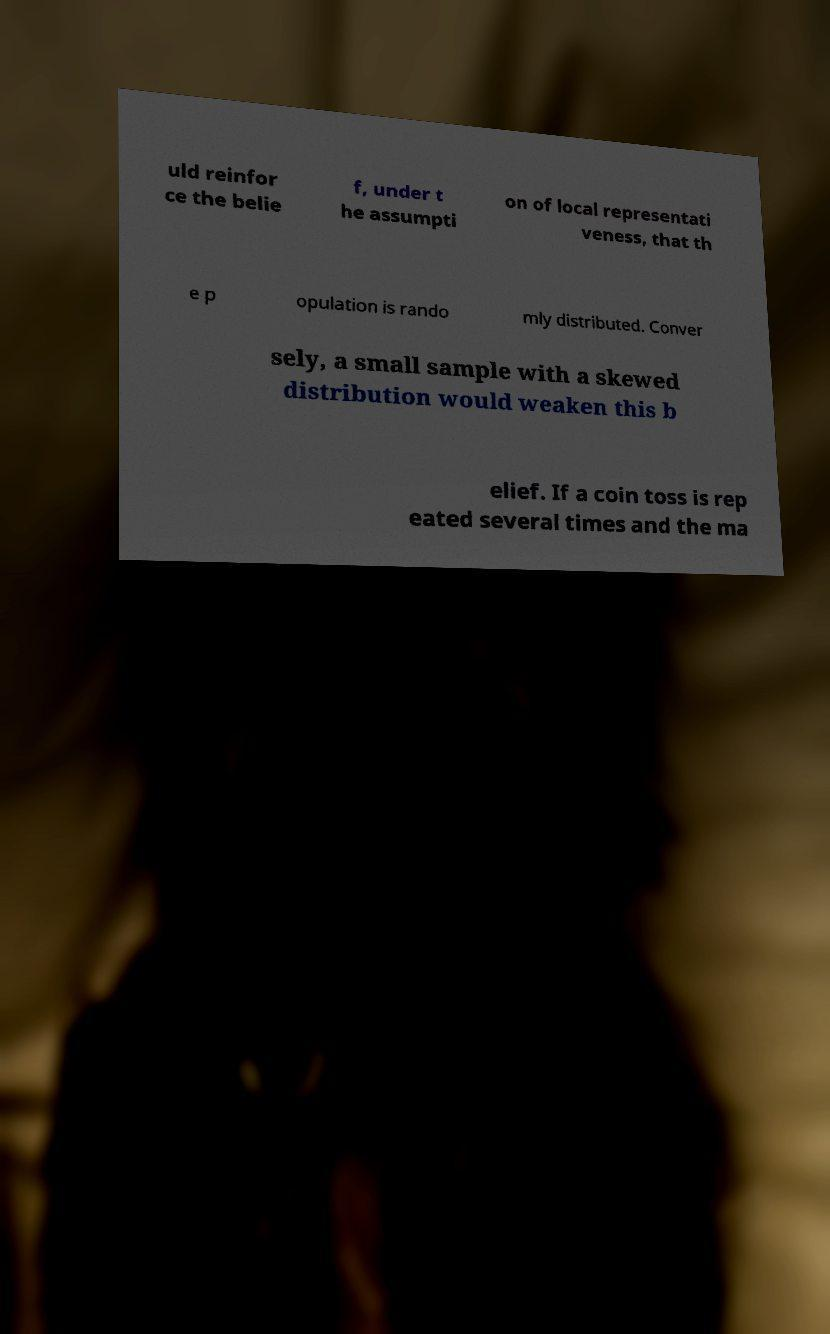Could you extract and type out the text from this image? uld reinfor ce the belie f, under t he assumpti on of local representati veness, that th e p opulation is rando mly distributed. Conver sely, a small sample with a skewed distribution would weaken this b elief. If a coin toss is rep eated several times and the ma 